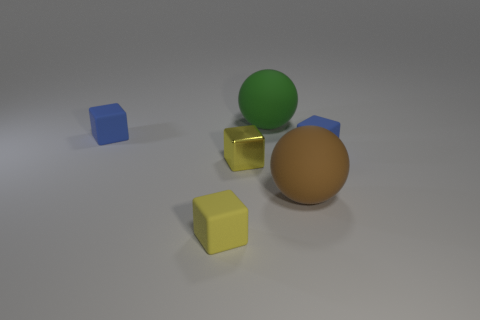How many blue blocks must be subtracted to get 1 blue blocks? 1 Add 4 small blocks. How many objects exist? 10 Subtract all cubes. How many objects are left? 2 Subtract 0 yellow cylinders. How many objects are left? 6 Subtract all green rubber spheres. Subtract all rubber balls. How many objects are left? 3 Add 3 large brown rubber balls. How many large brown rubber balls are left? 4 Add 6 small yellow matte things. How many small yellow matte things exist? 7 